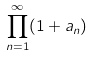<formula> <loc_0><loc_0><loc_500><loc_500>\prod _ { n = 1 } ^ { \infty } ( 1 + a _ { n } )</formula> 